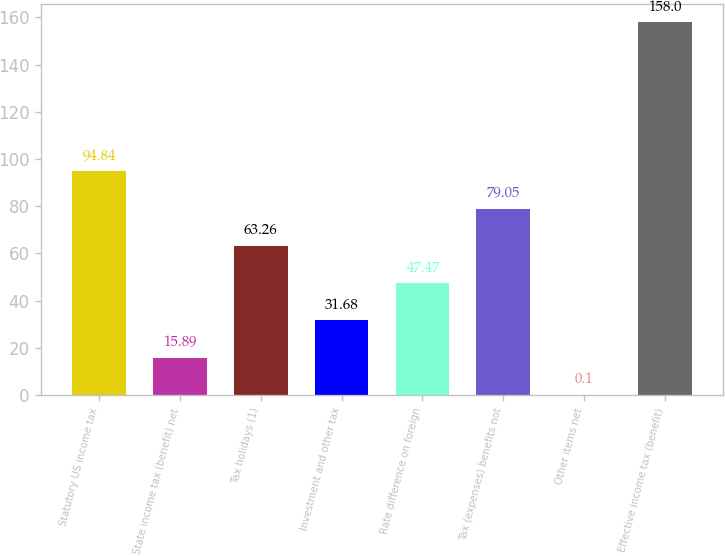Convert chart. <chart><loc_0><loc_0><loc_500><loc_500><bar_chart><fcel>Statutory US income tax<fcel>State income tax (benefit) net<fcel>Tax holidays (1)<fcel>Investment and other tax<fcel>Rate difference on foreign<fcel>Tax (expenses) benefits not<fcel>Other items net<fcel>Effective income tax (benefit)<nl><fcel>94.84<fcel>15.89<fcel>63.26<fcel>31.68<fcel>47.47<fcel>79.05<fcel>0.1<fcel>158<nl></chart> 